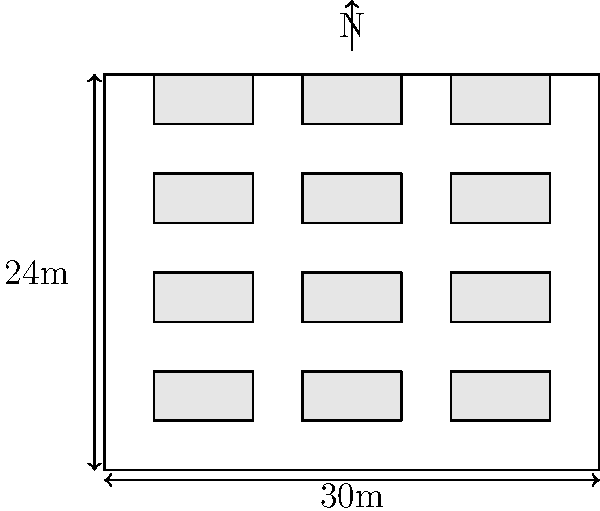Given the top-down diagram of a factory roof with dimensions 30m x 24m, what is the maximum number of 6m x 3m solar panels that can be installed if:
1. Panels must be oriented with the long side facing north
2. A 3m gap is required between panel rows for maintenance
3. A 1m border around the roof edge must be kept clear

Calculate the optimal layout and provide the total number of panels. Let's approach this step-by-step:

1. First, we need to calculate the available space for panels:
   - Width: 30m - 2m (border) = 28m
   - Length: 24m - 2m (border) = 22m

2. For panel orientation:
   - Panels will be 3m wide (short side) and 6m long (long side facing north)

3. Calculating rows:
   - Available length: 22m
   - Each row takes: 6m (panel) + 3m (gap) = 9m
   - Number of rows: $\lfloor 22 \div 9 \rfloor = 2$ rows
   - Note: The floor function $\lfloor \rfloor$ is used as we can't have partial rows

4. Calculating columns:
   - Available width: 28m
   - Each panel is 3m wide
   - Number of columns: $\lfloor 28 \div 3 \rfloor = 9$ columns

5. Total number of panels:
   - Panels = Rows × Columns
   - Panels = 2 × 9 = 18 panels

Therefore, the optimal layout allows for 18 solar panels to be installed on the factory roof.
Answer: 18 panels 